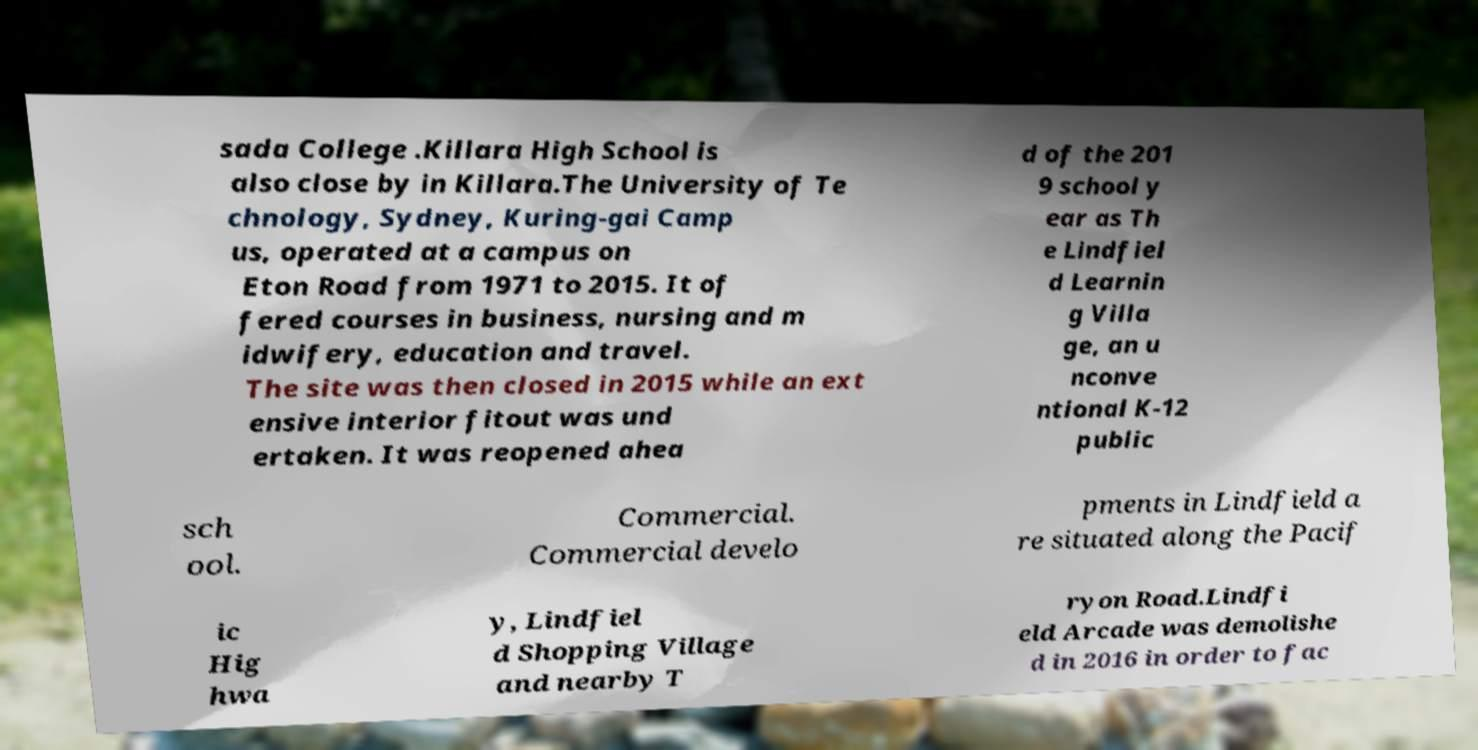Can you read and provide the text displayed in the image?This photo seems to have some interesting text. Can you extract and type it out for me? sada College .Killara High School is also close by in Killara.The University of Te chnology, Sydney, Kuring-gai Camp us, operated at a campus on Eton Road from 1971 to 2015. It of fered courses in business, nursing and m idwifery, education and travel. The site was then closed in 2015 while an ext ensive interior fitout was und ertaken. It was reopened ahea d of the 201 9 school y ear as Th e Lindfiel d Learnin g Villa ge, an u nconve ntional K-12 public sch ool. Commercial. Commercial develo pments in Lindfield a re situated along the Pacif ic Hig hwa y, Lindfiel d Shopping Village and nearby T ryon Road.Lindfi eld Arcade was demolishe d in 2016 in order to fac 